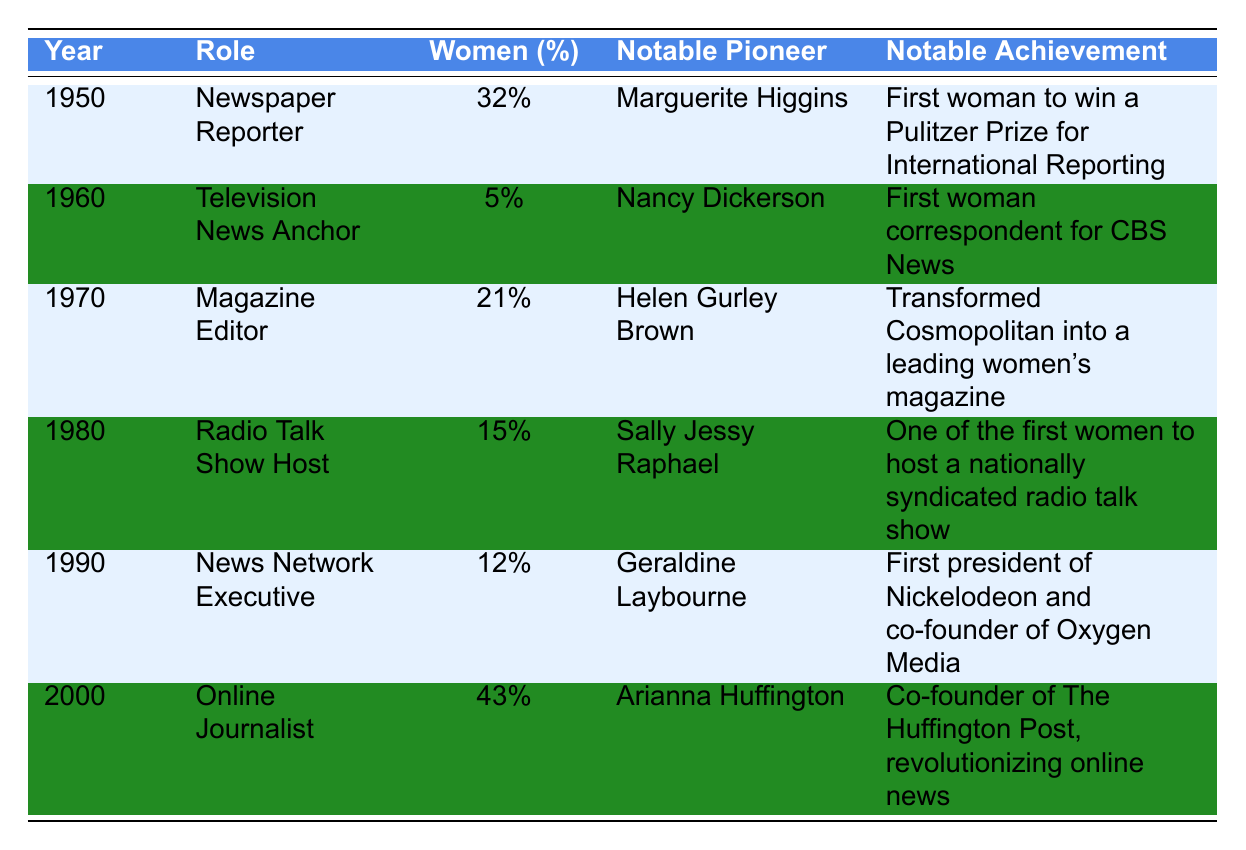What was the percentage of women in the role of newspaper reporters in 1950? From the table, in the year 1950 under the role of Newspaper Reporter, it shows that the percentage of women was 32%.
Answer: 32% Who was the notable pioneer for television news anchors in 1960? The table lists Nancy Dickerson as the notable pioneer for the role of Television News Anchor in 1960.
Answer: Nancy Dickerson What was the notable achievement of Helen Gurley Brown in 1970? According to the table, Helen Gurley Brown transformed Cosmopolitan into a leading women's magazine in 1970.
Answer: Transformed Cosmopolitan into a leading women's magazine In which role did Arianna Huffington make her notable achievement in 2000? The table indicates that Arianna Huffington was recognized for her role as an Online Journalist in the year 2000.
Answer: Online Journalist What is the average percentage of women across all roles listed in the table from 1950 to 2000? Summing up all the percentages: 32 + 5 + 21 + 15 + 12 + 43 = 128. Then, divide by the number of roles (6): 128 / 6 = 21.33%.
Answer: 21.33% Was the percentage of women higher in 2000 than in 1990? From the table, the percentage of women in 2000 was 43%, while in 1990 it was 12%. Since 43% is greater than 12%, the statement is true.
Answer: Yes Which role had the highest percentage of women and what was that percentage? By examining the table, Online Journalist in 2000 had the highest percentage of women at 43%.
Answer: 43% What was the trend in the percentage of women in media roles from 1950 to 2000? Looking at the table data, the percentages show variation: it increased from 32% in 1950 to 43% in 2000, indicating a general upward trend despite fluctuations.
Answer: General upward trend How many roles had a percentage of women below 20%? The roles with percentages below 20% are Television News Anchor (5%), Magazine Editor (21%), and Radio Talk Show Host (15%). Therefore, 3 roles had percentages below 20%.
Answer: 2 roles In which year did women occupy the lowest percentage of roles in media, based on the table? Analyzing the table, in 1960 the percentage of women in the role of Television News Anchor was the lowest at 5%.
Answer: 1960 